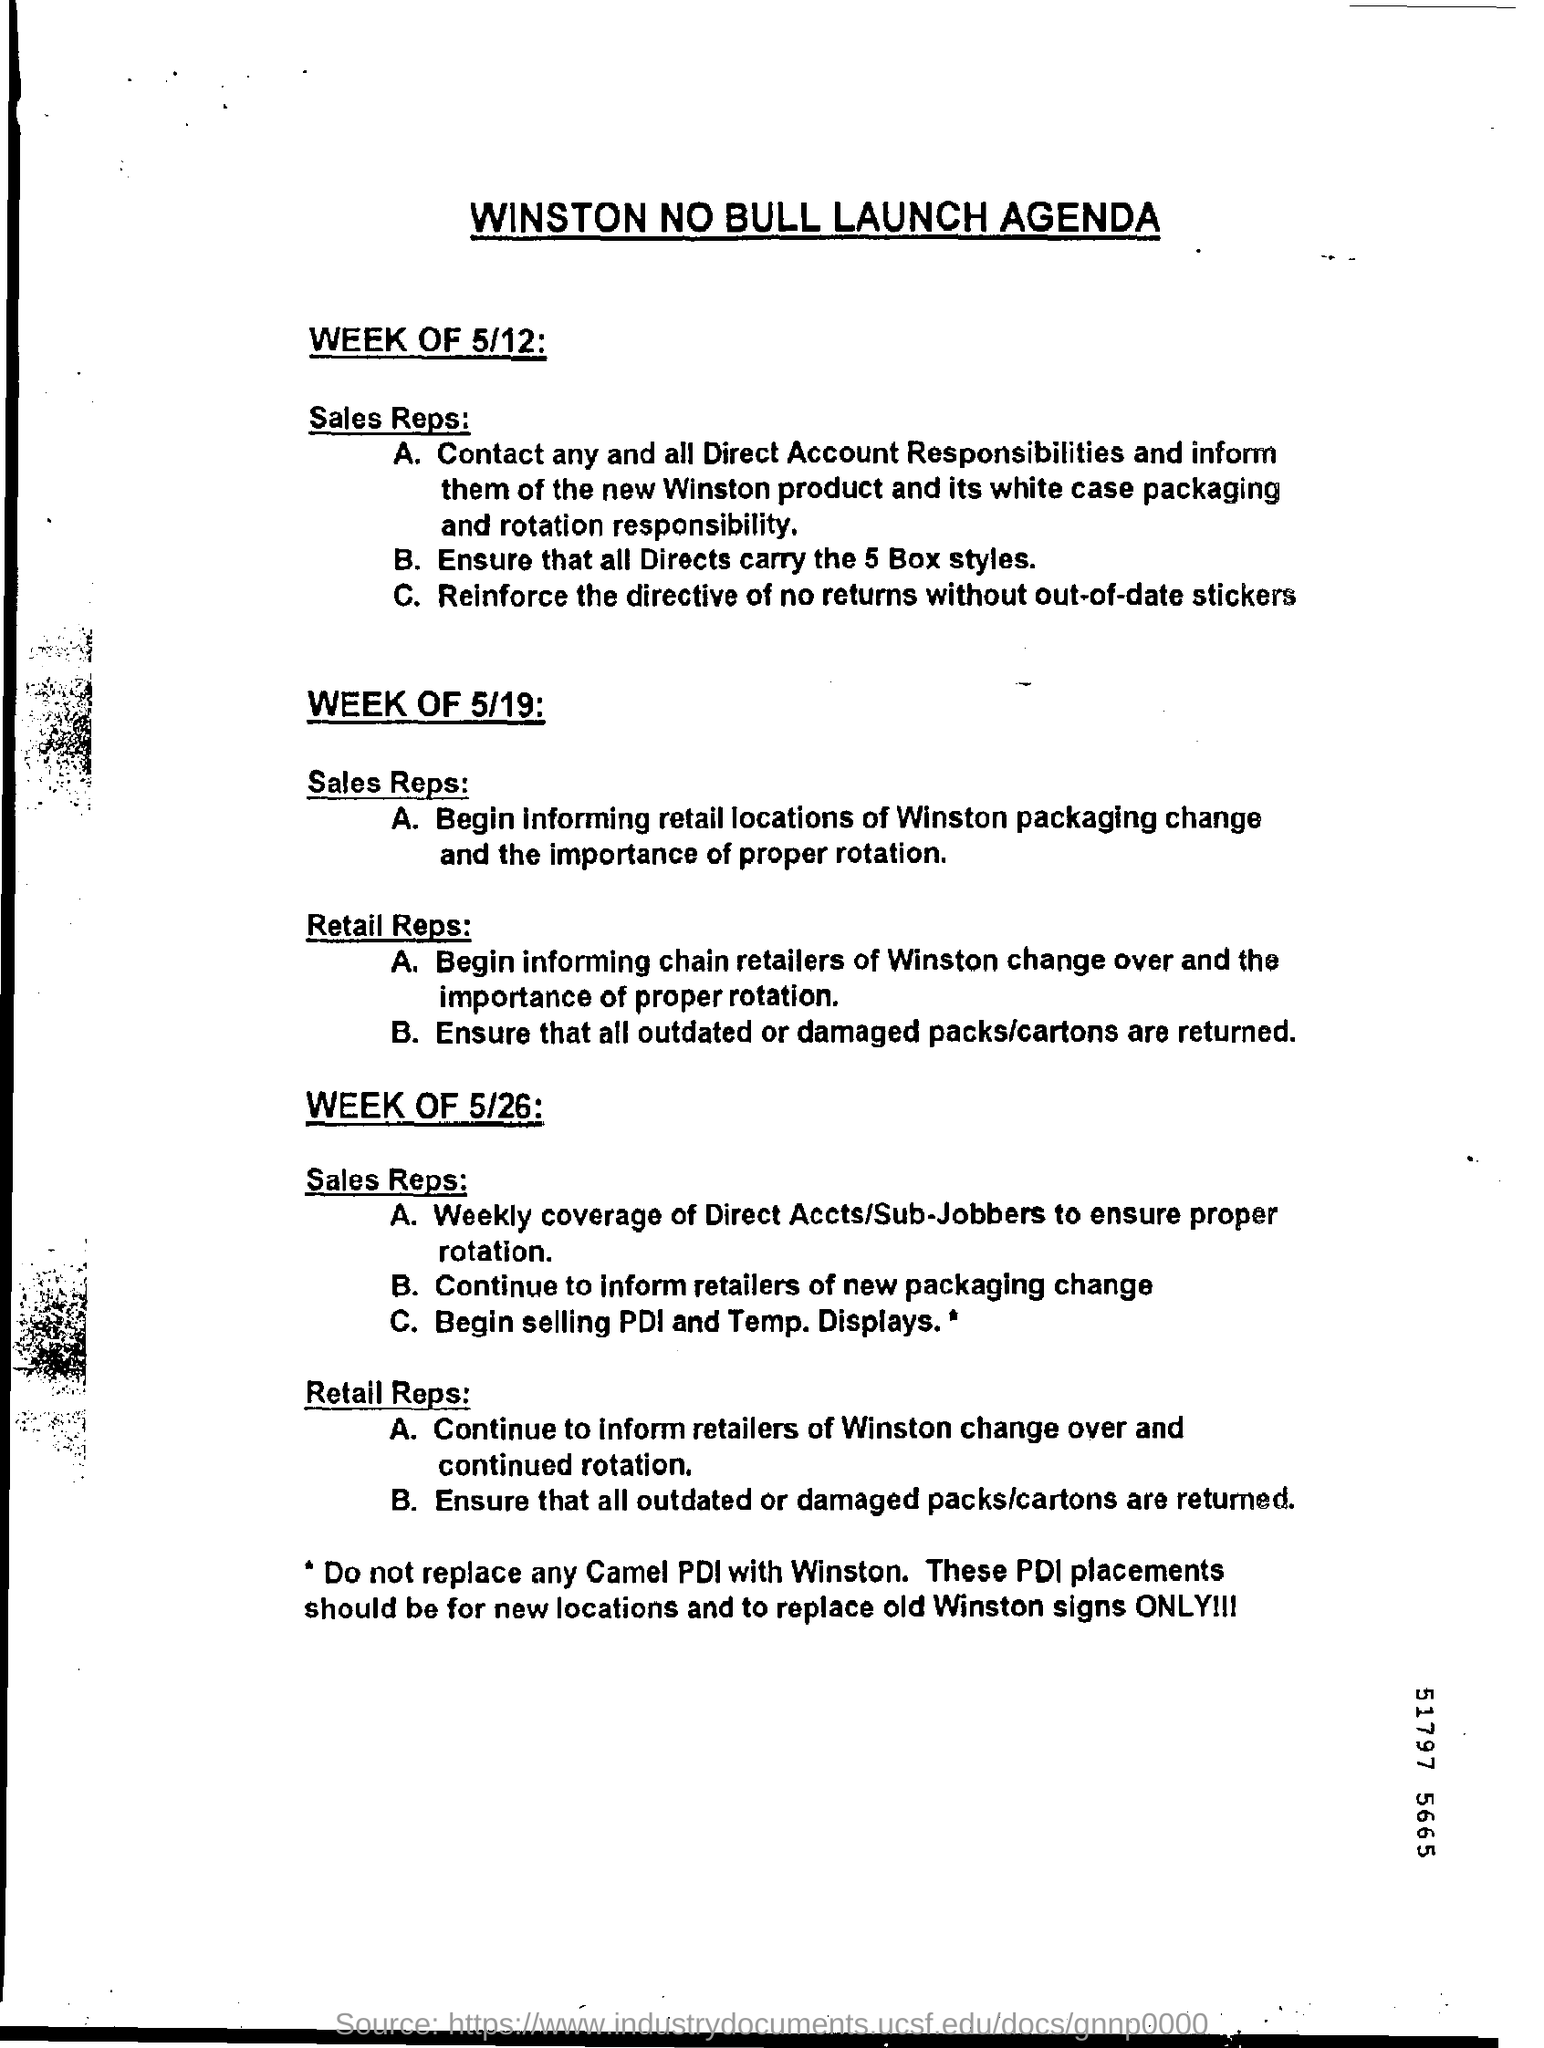What is the heading of page?
Provide a succinct answer. Winston no bull launch agenda. How many box styles must be ensured that all directs are carrying ?
Your answer should be very brief. 5. 